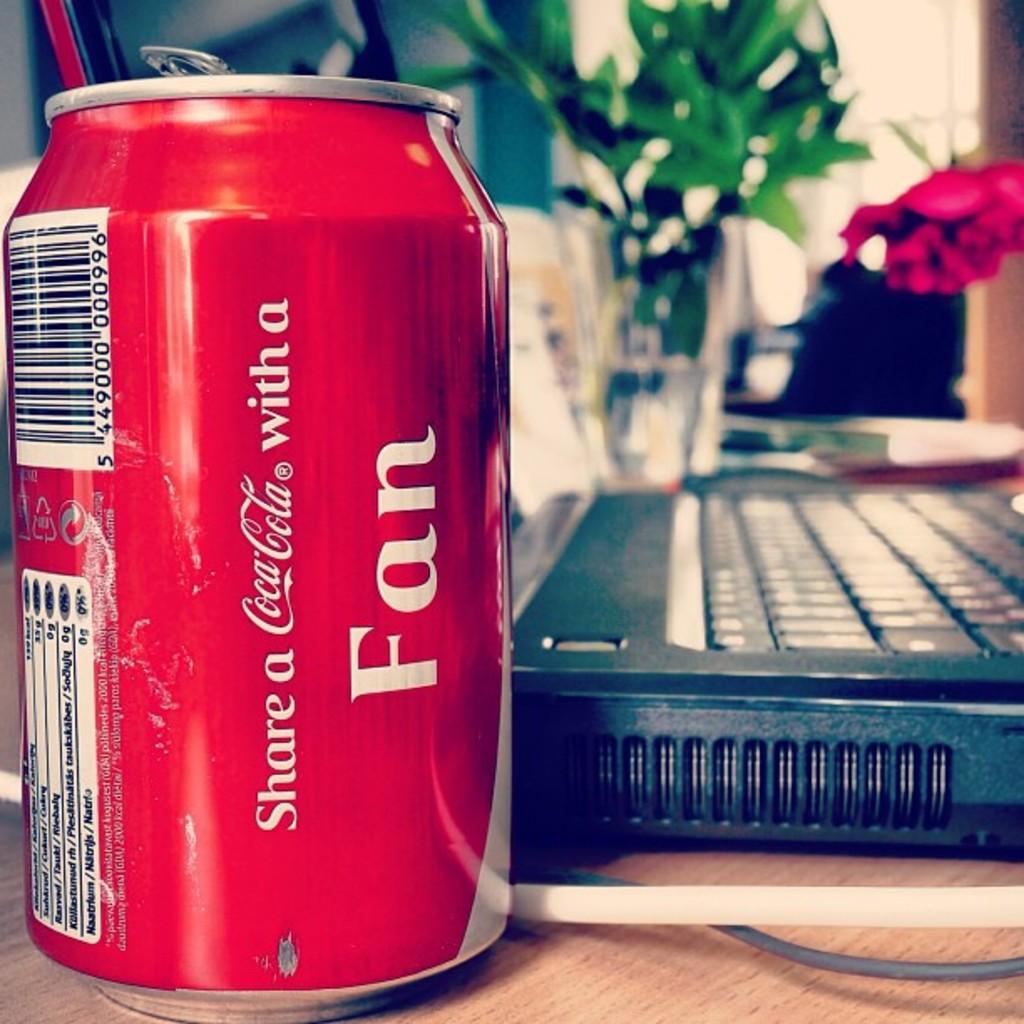Who does the can say to share a coca-cola with?
Ensure brevity in your answer.  Fan. What brand of soft drink is this?
Make the answer very short. Coca cola. 